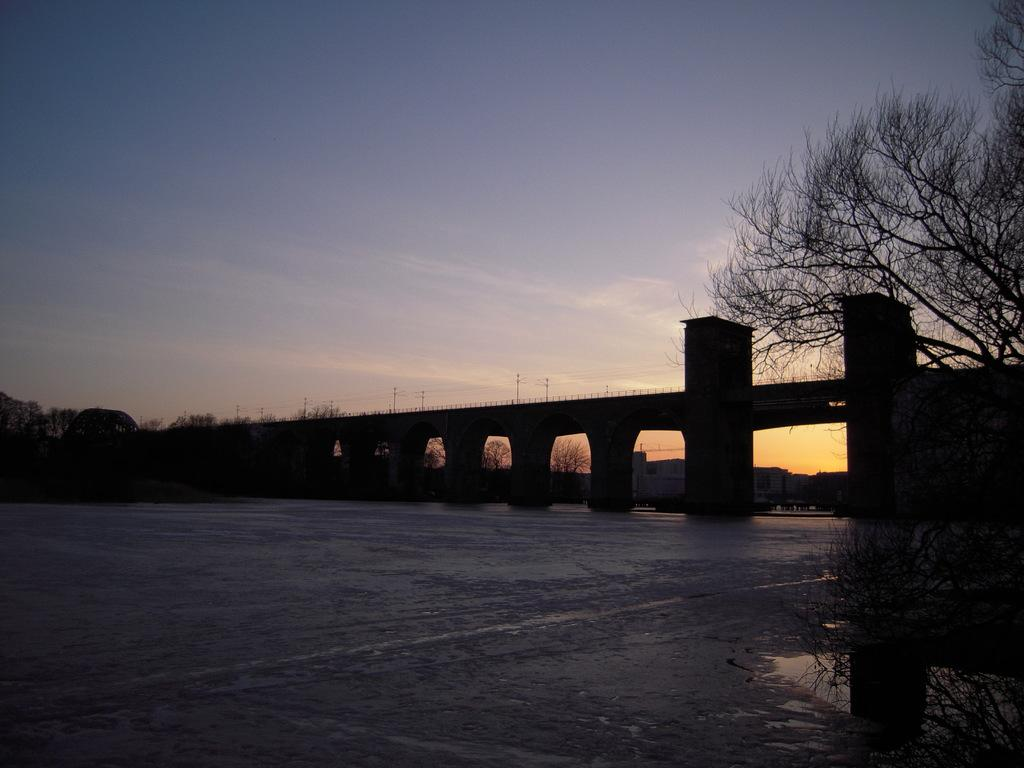What structure is the main subject of the image? There is a bridge in the image. Where is the bridge located? The bridge is constructed on a water surface. What type of vegetation can be seen in the image? There is a tree on the right side of the image. What type of apparatus is used to catch fish in the image? There is no apparatus for catching fish present in the image. What can be seen inside the can on the left side of the image? There is no can present in the image. What type of flowers are in the vase on the table in the image? There is no vase or flowers present in the image. 